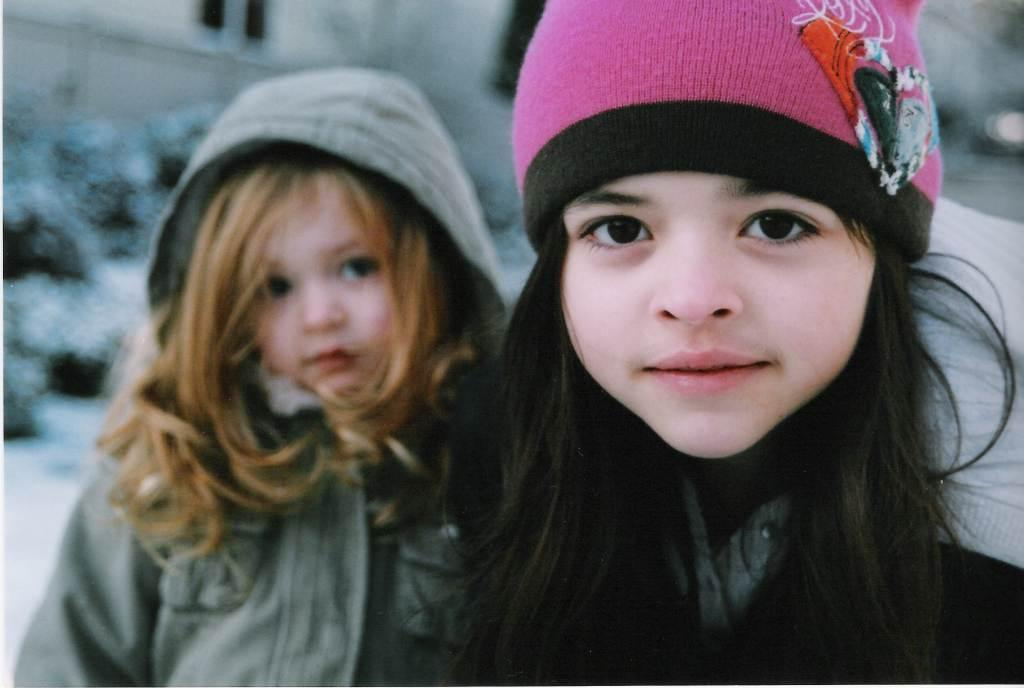What is the main subject on the right side of the image? There is a little girl on the right side of the image. What is the little girl doing in the image? The girl is looking at this side. What color is the cap the little girl is wearing? The girl is wearing a pink color cap. What is the main subject on the left side of the image? There is another girl on the left side of the image. What is the girl on the left side wearing? The girl on the left side is wearing a coat. Can you see any sheep in the image? There are no sheep present in the image. What type of harmony is being played by the girls in the image? There is no indication of any music or harmony in the image. 